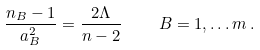<formula> <loc_0><loc_0><loc_500><loc_500>\frac { n _ { B } - 1 } { a _ { B } ^ { 2 } } = \frac { 2 \Lambda } { n - 2 } \quad B = 1 , \dots m \, .</formula> 